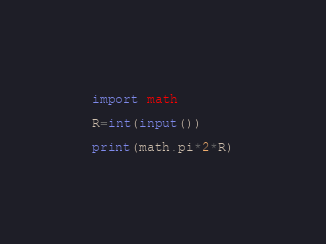<code> <loc_0><loc_0><loc_500><loc_500><_Python_>import math

R=int(input())

print(math.pi*2*R)

</code> 